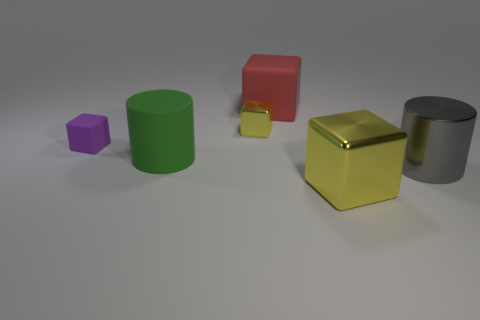Are there any tiny yellow balls that have the same material as the large green object?
Provide a succinct answer. No. Is the gray shiny thing the same size as the green rubber cylinder?
Give a very brief answer. Yes. What number of balls are either large gray metallic objects or large yellow things?
Ensure brevity in your answer.  0. There is a thing that is the same color as the tiny shiny block; what is it made of?
Ensure brevity in your answer.  Metal. What number of small yellow metal things have the same shape as the purple matte object?
Keep it short and to the point. 1. Is the number of big things in front of the tiny purple cube greater than the number of red rubber things that are in front of the gray shiny thing?
Your answer should be very brief. Yes. There is a metallic block in front of the large green object; is its color the same as the tiny metallic thing?
Provide a short and direct response. Yes. What is the size of the purple object?
Offer a terse response. Small. There is a yellow thing that is the same size as the gray object; what is its material?
Keep it short and to the point. Metal. There is a small thing to the right of the green object; what color is it?
Your answer should be very brief. Yellow. 